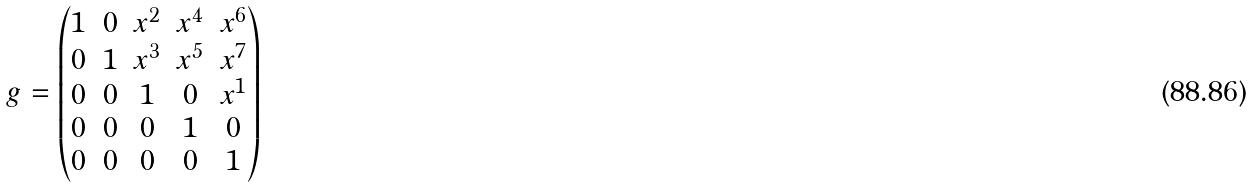Convert formula to latex. <formula><loc_0><loc_0><loc_500><loc_500>g = \begin{pmatrix} 1 & 0 & x ^ { 2 } & x ^ { 4 } & x ^ { 6 } \\ 0 & 1 & x ^ { 3 } & x ^ { 5 } & x ^ { 7 } \\ 0 & 0 & 1 & 0 & x ^ { 1 } \\ 0 & 0 & 0 & 1 & 0 \\ 0 & 0 & 0 & 0 & 1 \\ \end{pmatrix}</formula> 